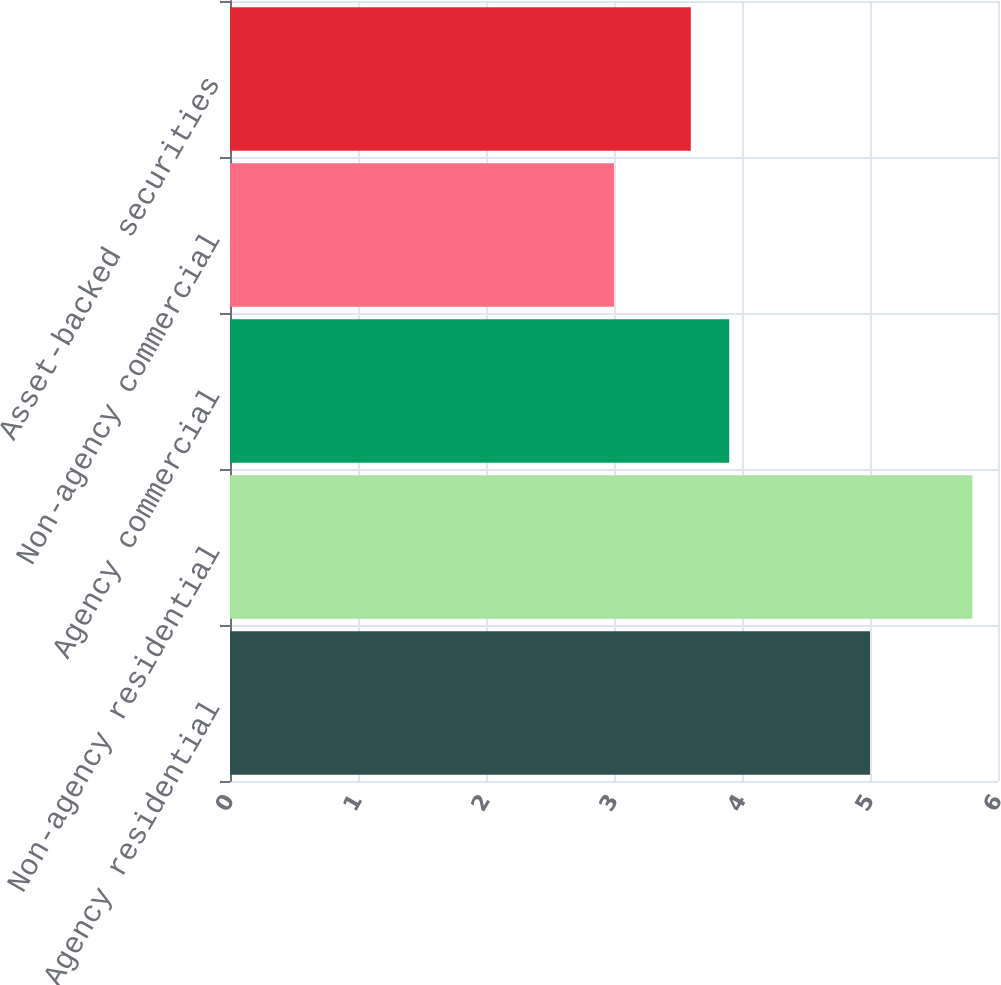Convert chart. <chart><loc_0><loc_0><loc_500><loc_500><bar_chart><fcel>Agency residential<fcel>Non-agency residential<fcel>Agency commercial<fcel>Non-agency commercial<fcel>Asset-backed securities<nl><fcel>5<fcel>5.8<fcel>3.9<fcel>3<fcel>3.6<nl></chart> 